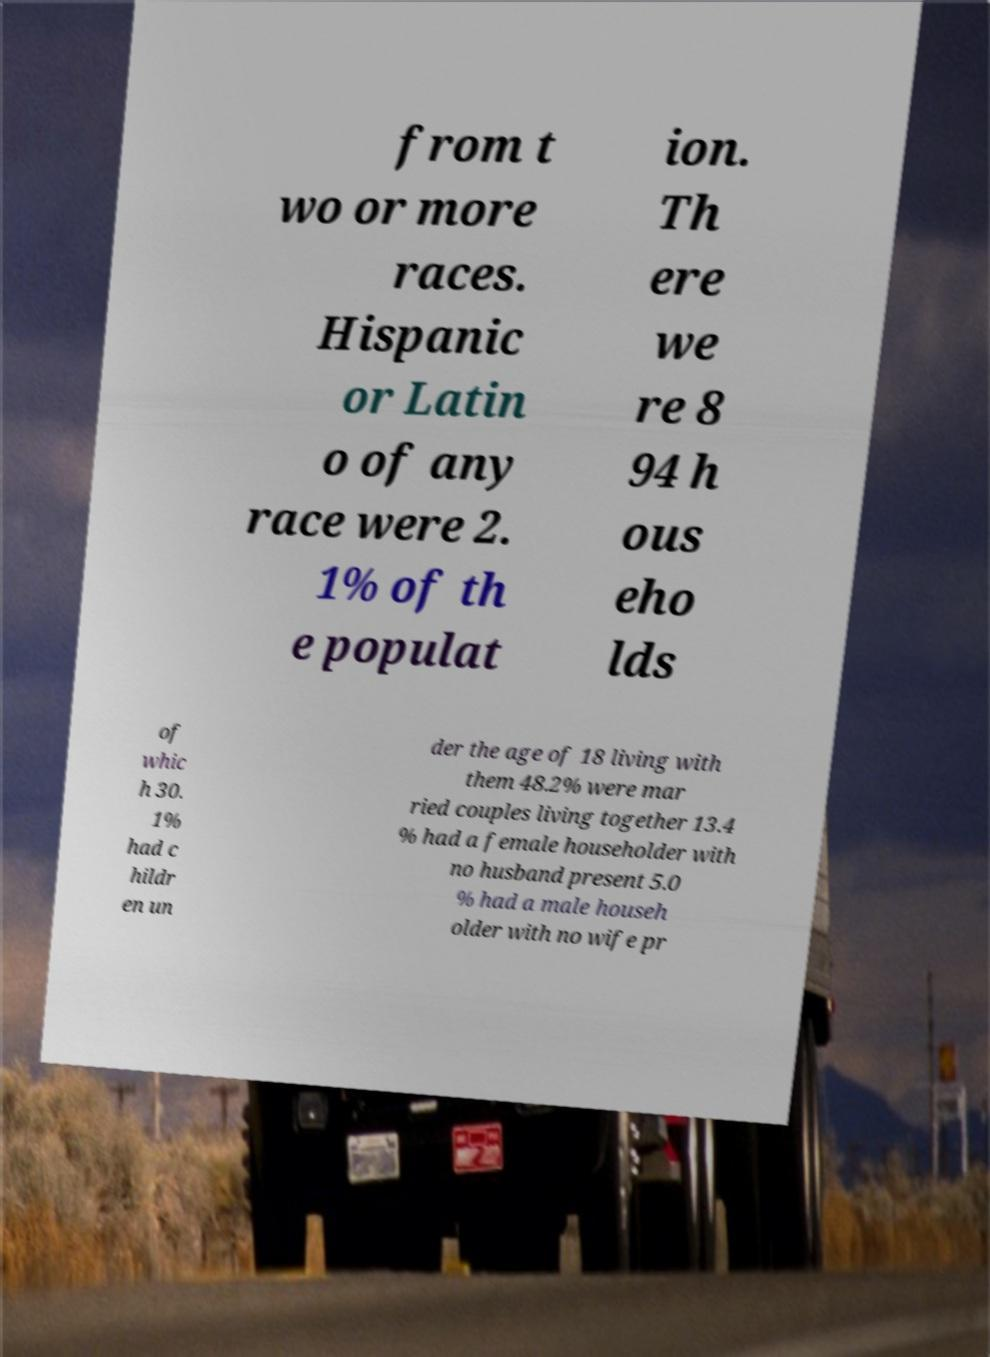Please identify and transcribe the text found in this image. from t wo or more races. Hispanic or Latin o of any race were 2. 1% of th e populat ion. Th ere we re 8 94 h ous eho lds of whic h 30. 1% had c hildr en un der the age of 18 living with them 48.2% were mar ried couples living together 13.4 % had a female householder with no husband present 5.0 % had a male househ older with no wife pr 